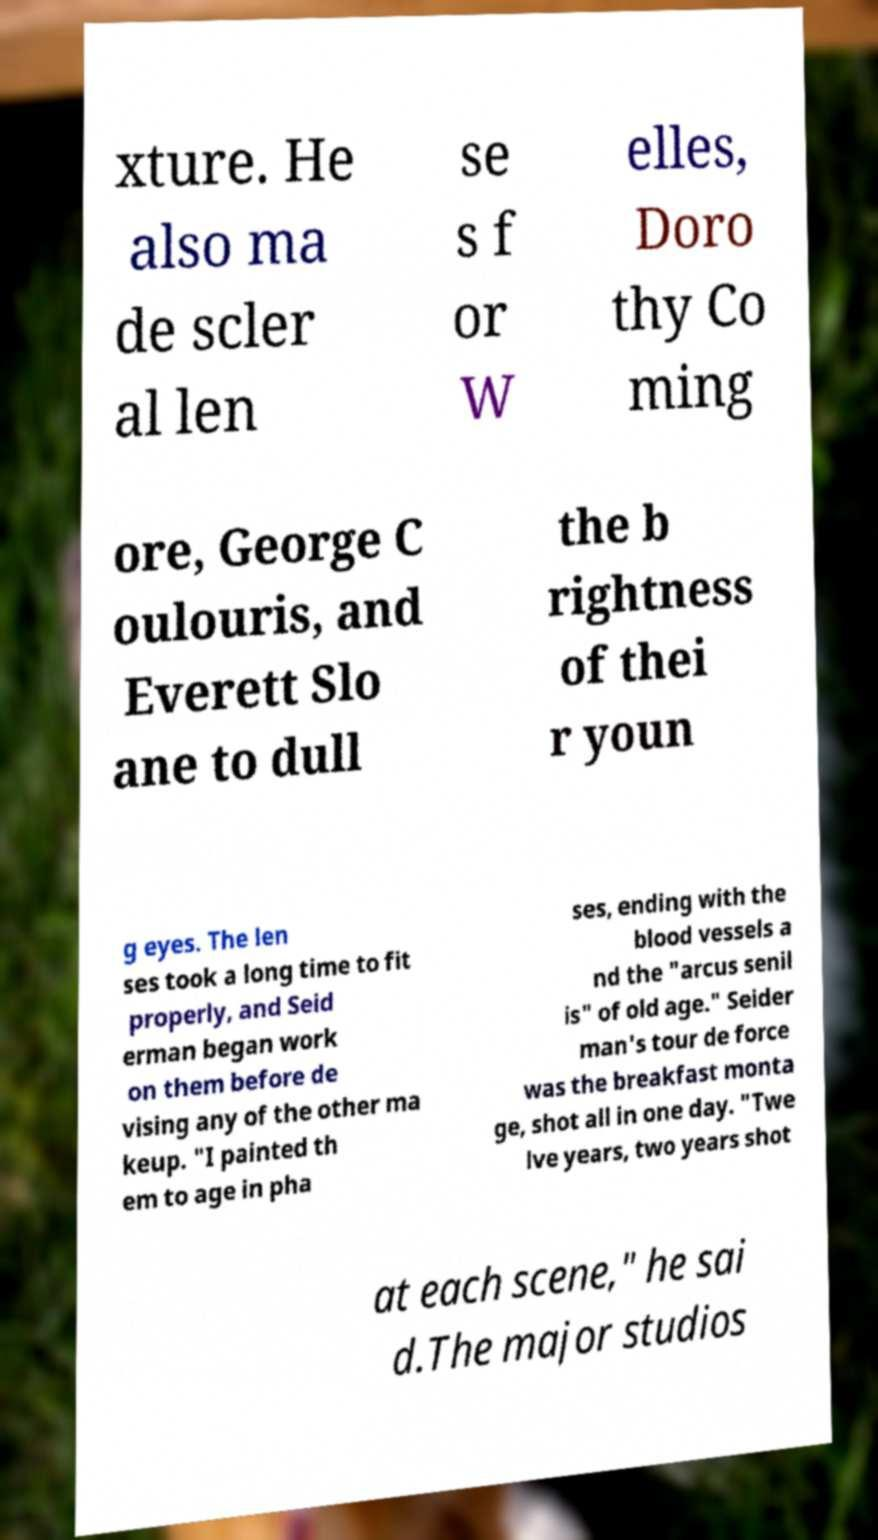I need the written content from this picture converted into text. Can you do that? xture. He also ma de scler al len se s f or W elles, Doro thy Co ming ore, George C oulouris, and Everett Slo ane to dull the b rightness of thei r youn g eyes. The len ses took a long time to fit properly, and Seid erman began work on them before de vising any of the other ma keup. "I painted th em to age in pha ses, ending with the blood vessels a nd the "arcus senil is" of old age." Seider man's tour de force was the breakfast monta ge, shot all in one day. "Twe lve years, two years shot at each scene," he sai d.The major studios 